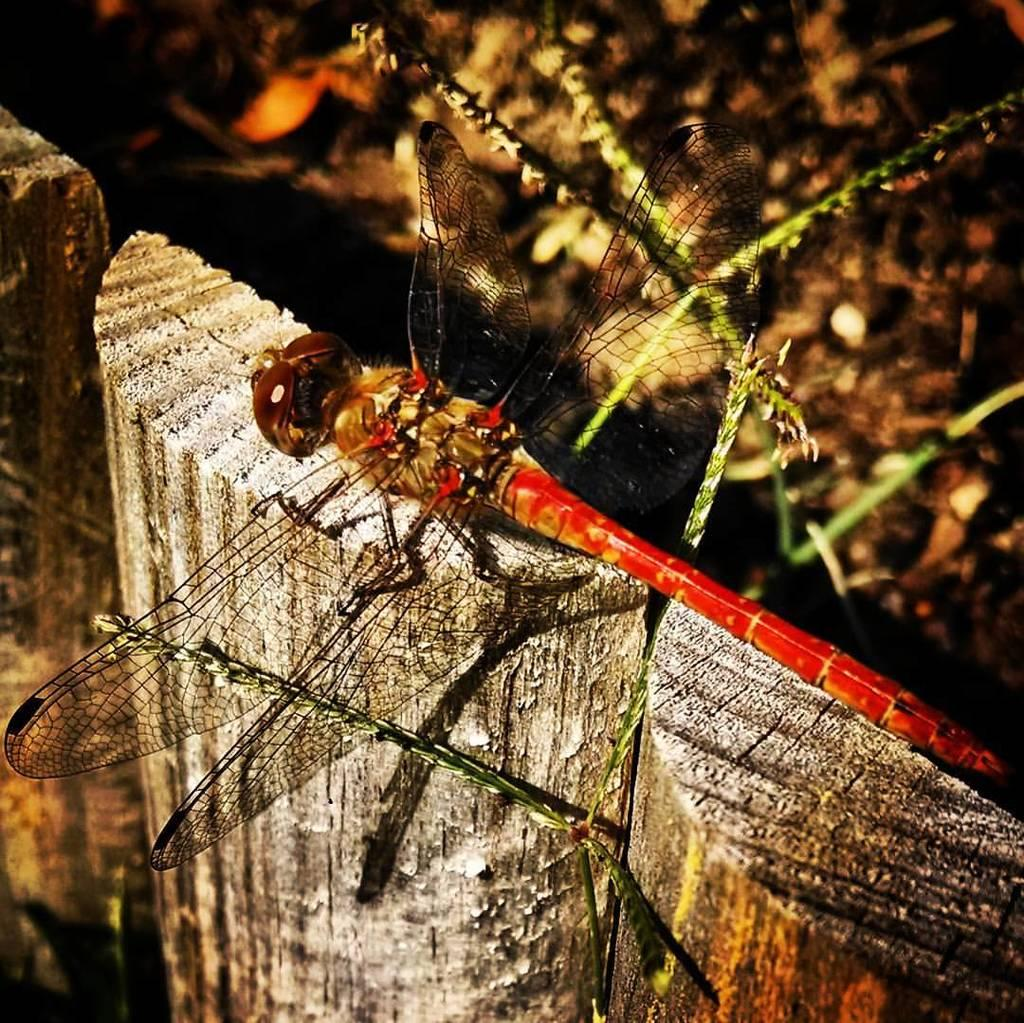What is present in the image? There is a fly in the image. Where is the fly located? The fly is on a wooden log. How many legs does the turkey have in the image? There is no turkey present in the image, so it is not possible to determine the number of legs it might have. 